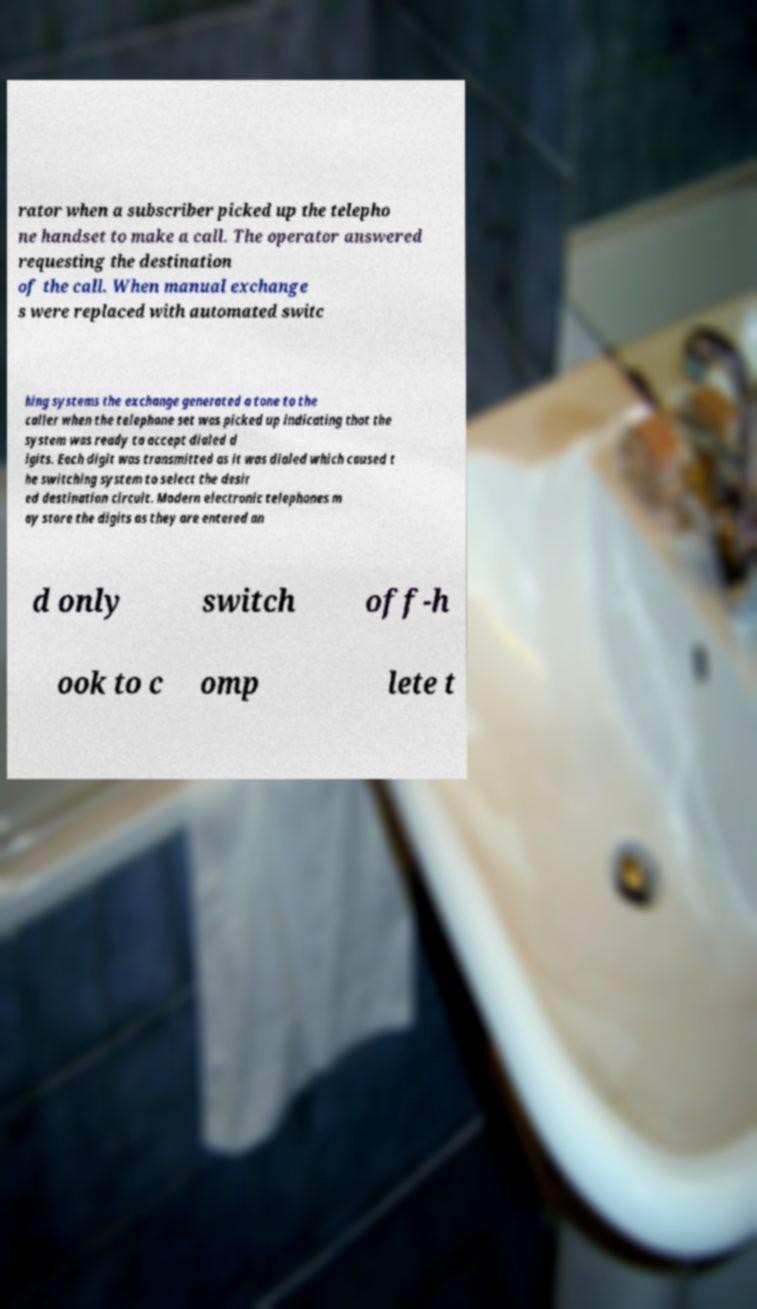What messages or text are displayed in this image? I need them in a readable, typed format. rator when a subscriber picked up the telepho ne handset to make a call. The operator answered requesting the destination of the call. When manual exchange s were replaced with automated switc hing systems the exchange generated a tone to the caller when the telephone set was picked up indicating that the system was ready to accept dialed d igits. Each digit was transmitted as it was dialed which caused t he switching system to select the desir ed destination circuit. Modern electronic telephones m ay store the digits as they are entered an d only switch off-h ook to c omp lete t 